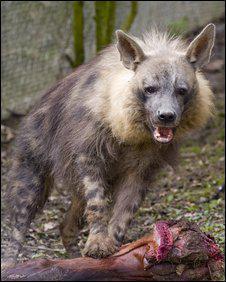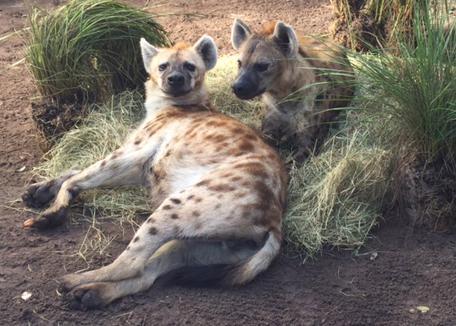The first image is the image on the left, the second image is the image on the right. For the images displayed, is the sentence "Neither image shows a carcass near a hyena, and one image shows exactly two hyenas, with one behind the other." factually correct? Answer yes or no. No. 